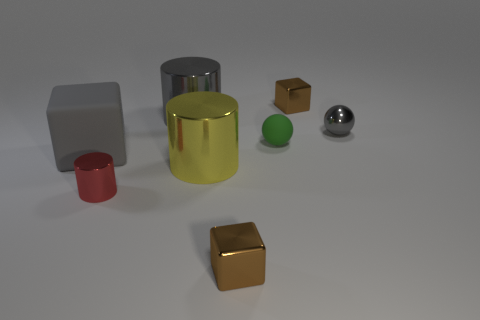Is the number of gray balls that are in front of the large yellow metal object greater than the number of matte blocks?
Your answer should be compact. No. What number of things are either objects that are in front of the yellow thing or big gray objects behind the green rubber object?
Your answer should be very brief. 3. What size is the yellow cylinder that is the same material as the tiny red cylinder?
Your response must be concise. Large. There is a brown thing that is behind the large gray metal object; is its shape the same as the small gray metallic object?
Offer a very short reply. No. What is the size of the ball that is the same color as the big block?
Provide a short and direct response. Small. What number of gray objects are tiny cubes or matte balls?
Provide a short and direct response. 0. What number of other objects are there of the same shape as the green object?
Offer a very short reply. 1. There is a thing that is both to the left of the big gray shiny cylinder and in front of the yellow shiny cylinder; what shape is it?
Make the answer very short. Cylinder. Are there any tiny red cylinders right of the green sphere?
Keep it short and to the point. No. There is another gray object that is the same shape as the tiny matte thing; what is its size?
Your answer should be compact. Small. 